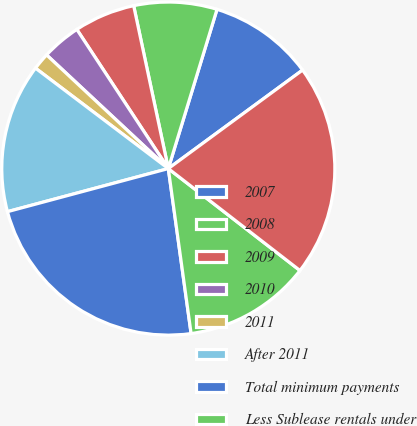Convert chart to OTSL. <chart><loc_0><loc_0><loc_500><loc_500><pie_chart><fcel>2007<fcel>2008<fcel>2009<fcel>2010<fcel>2011<fcel>After 2011<fcel>Total minimum payments<fcel>Less Sublease rentals under<fcel>Net minimum payment required<nl><fcel>10.2%<fcel>8.06%<fcel>5.92%<fcel>3.79%<fcel>1.65%<fcel>14.47%<fcel>23.02%<fcel>12.33%<fcel>20.56%<nl></chart> 